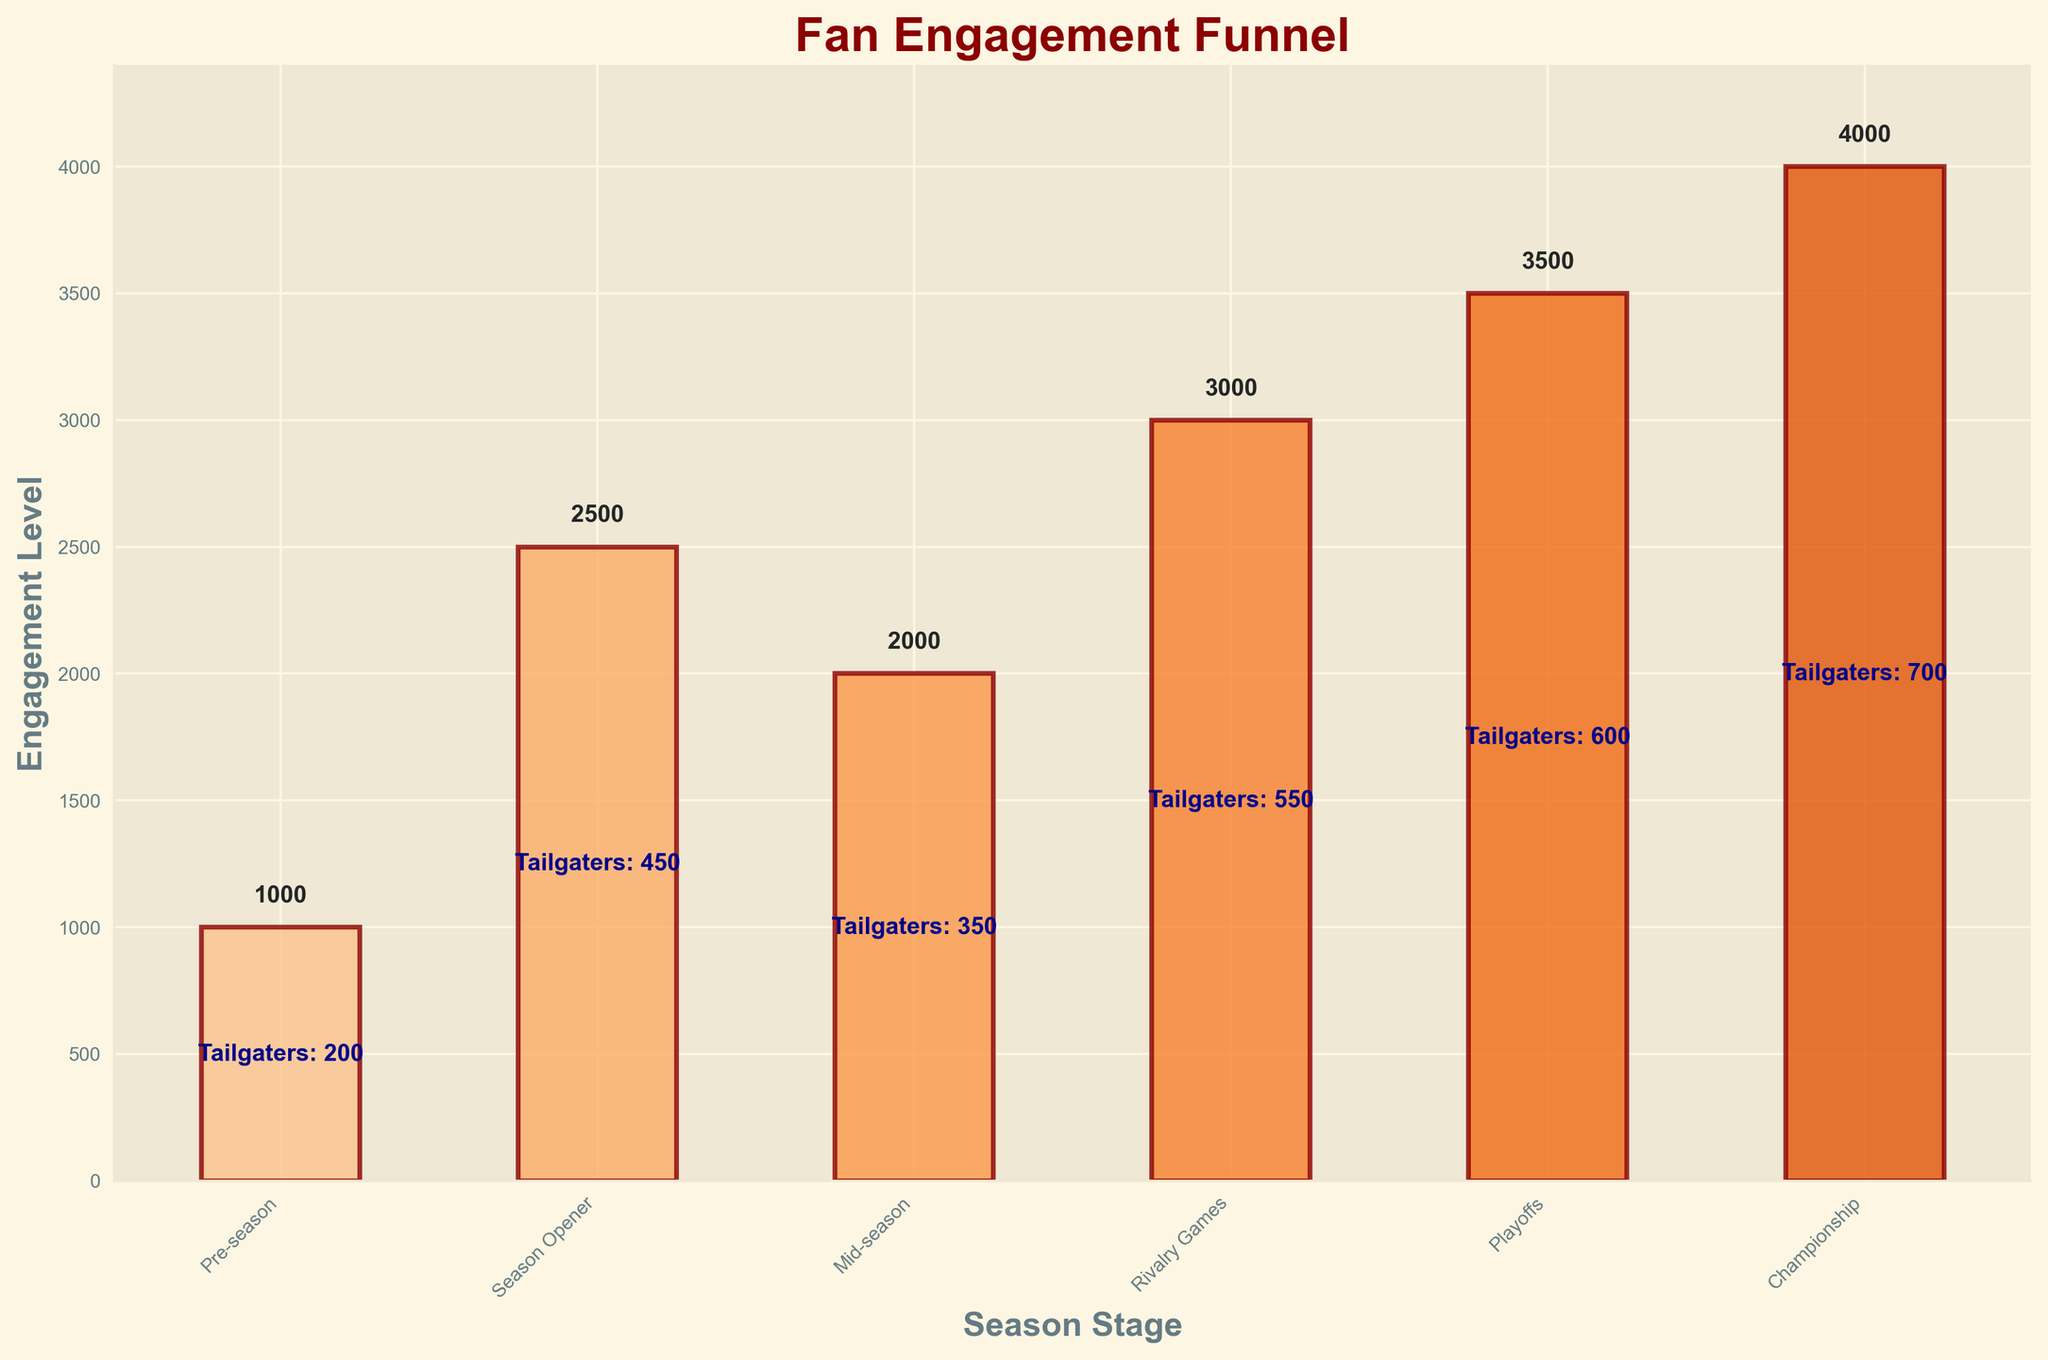What is the title of the figure? The title of the figure is labeled at the top of the chart. By reading this label, you can identify the title.
Answer: Fan Engagement Funnel How many stages are represented in the figure? The stages are individual bars on the chart. You can count the bars to determine the number of stages.
Answer: 6 Which stage has the highest engagement level? By looking at the heights of the bars, you can see which one reaches the highest point on the y-axis.
Answer: Championship What are the engagement levels during the Pre-season and the Playoffs? You can read the heights of the respective bars for these stages and check the labels next to them for their exact values.
Answer: 1000 (Pre-season), 3500 (Playoffs) What is the difference in engagement level between Mid-season and Playoffs? Find the engagement levels for both Mid-season (2000) and Playoffs (3500). Subtract the Mid-season value from the Playoffs value to find the difference.
Answer: 1500 How does the number of tailgaters change from Season Opener to Championship? Look at the text labels inside each bar to find the number of tailgaters for these stages: Season Opener (450) and Championship (700). Subtract the former from the latter.
Answer: 250 Which stage has more tailgaters: Rivalry Games or Mid-season? Compare the tailgater numbers in the text labels for Rivalry Games (550) and Mid-season (350).
Answer: Rivalry Games At which stage does the engagement level increase the most from the previous stage? Calculate the differences between successive engagement levels for each stage and identify the stage with the highest increase: pre-season to season opener (1500), season opener to mid-season (-500), mid-season to rivalry games (1000), rivalry games to playoffs (500), playoffs to championship (500).
Answer: Pre-season to Season Opener What is the average engagement level over all the stages? Sum the engagement levels (1000 + 2500 + 2000 + 3000 + 3500 + 4000 = 16000) and divide by the number of stages (6).
Answer: 2667 Is there any stage where the engagement level decreases compared to the previous stage? Compare engagement levels from each stage to its subsequent stage. From Season Opener (2500) to Mid-season (2000), the engagement level decreases.
Answer: Yes, from Season Opener to Mid-season 